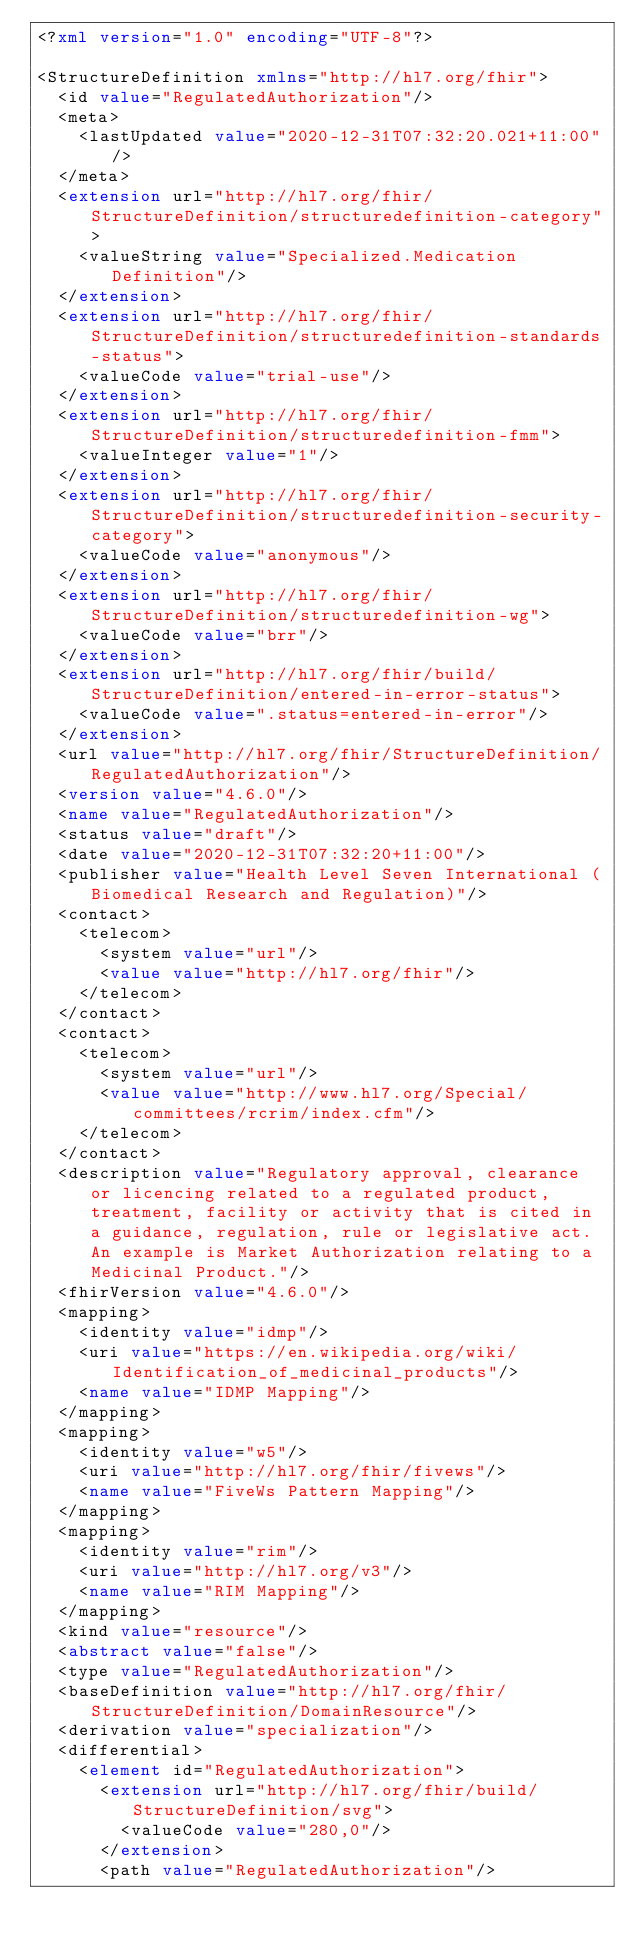Convert code to text. <code><loc_0><loc_0><loc_500><loc_500><_XML_><?xml version="1.0" encoding="UTF-8"?>

<StructureDefinition xmlns="http://hl7.org/fhir">
  <id value="RegulatedAuthorization"/>
  <meta>
    <lastUpdated value="2020-12-31T07:32:20.021+11:00"/>
  </meta>
  <extension url="http://hl7.org/fhir/StructureDefinition/structuredefinition-category">
    <valueString value="Specialized.Medication Definition"/>
  </extension>
  <extension url="http://hl7.org/fhir/StructureDefinition/structuredefinition-standards-status">
    <valueCode value="trial-use"/>
  </extension>
  <extension url="http://hl7.org/fhir/StructureDefinition/structuredefinition-fmm">
    <valueInteger value="1"/>
  </extension>
  <extension url="http://hl7.org/fhir/StructureDefinition/structuredefinition-security-category">
    <valueCode value="anonymous"/>
  </extension>
  <extension url="http://hl7.org/fhir/StructureDefinition/structuredefinition-wg">
    <valueCode value="brr"/>
  </extension>
  <extension url="http://hl7.org/fhir/build/StructureDefinition/entered-in-error-status">
    <valueCode value=".status=entered-in-error"/>
  </extension>
  <url value="http://hl7.org/fhir/StructureDefinition/RegulatedAuthorization"/>
  <version value="4.6.0"/>
  <name value="RegulatedAuthorization"/>
  <status value="draft"/>
  <date value="2020-12-31T07:32:20+11:00"/>
  <publisher value="Health Level Seven International (Biomedical Research and Regulation)"/>
  <contact>
    <telecom>
      <system value="url"/>
      <value value="http://hl7.org/fhir"/>
    </telecom>
  </contact>
  <contact>
    <telecom>
      <system value="url"/>
      <value value="http://www.hl7.org/Special/committees/rcrim/index.cfm"/>
    </telecom>
  </contact>
  <description value="Regulatory approval, clearance or licencing related to a regulated product, treatment, facility or activity that is cited in a guidance, regulation, rule or legislative act. An example is Market Authorization relating to a Medicinal Product."/>
  <fhirVersion value="4.6.0"/>
  <mapping>
    <identity value="idmp"/>
    <uri value="https://en.wikipedia.org/wiki/Identification_of_medicinal_products"/>
    <name value="IDMP Mapping"/>
  </mapping>
  <mapping>
    <identity value="w5"/>
    <uri value="http://hl7.org/fhir/fivews"/>
    <name value="FiveWs Pattern Mapping"/>
  </mapping>
  <mapping>
    <identity value="rim"/>
    <uri value="http://hl7.org/v3"/>
    <name value="RIM Mapping"/>
  </mapping>
  <kind value="resource"/>
  <abstract value="false"/>
  <type value="RegulatedAuthorization"/>
  <baseDefinition value="http://hl7.org/fhir/StructureDefinition/DomainResource"/>
  <derivation value="specialization"/>
  <differential>
    <element id="RegulatedAuthorization">
      <extension url="http://hl7.org/fhir/build/StructureDefinition/svg">
        <valueCode value="280,0"/>
      </extension>
      <path value="RegulatedAuthorization"/></code> 